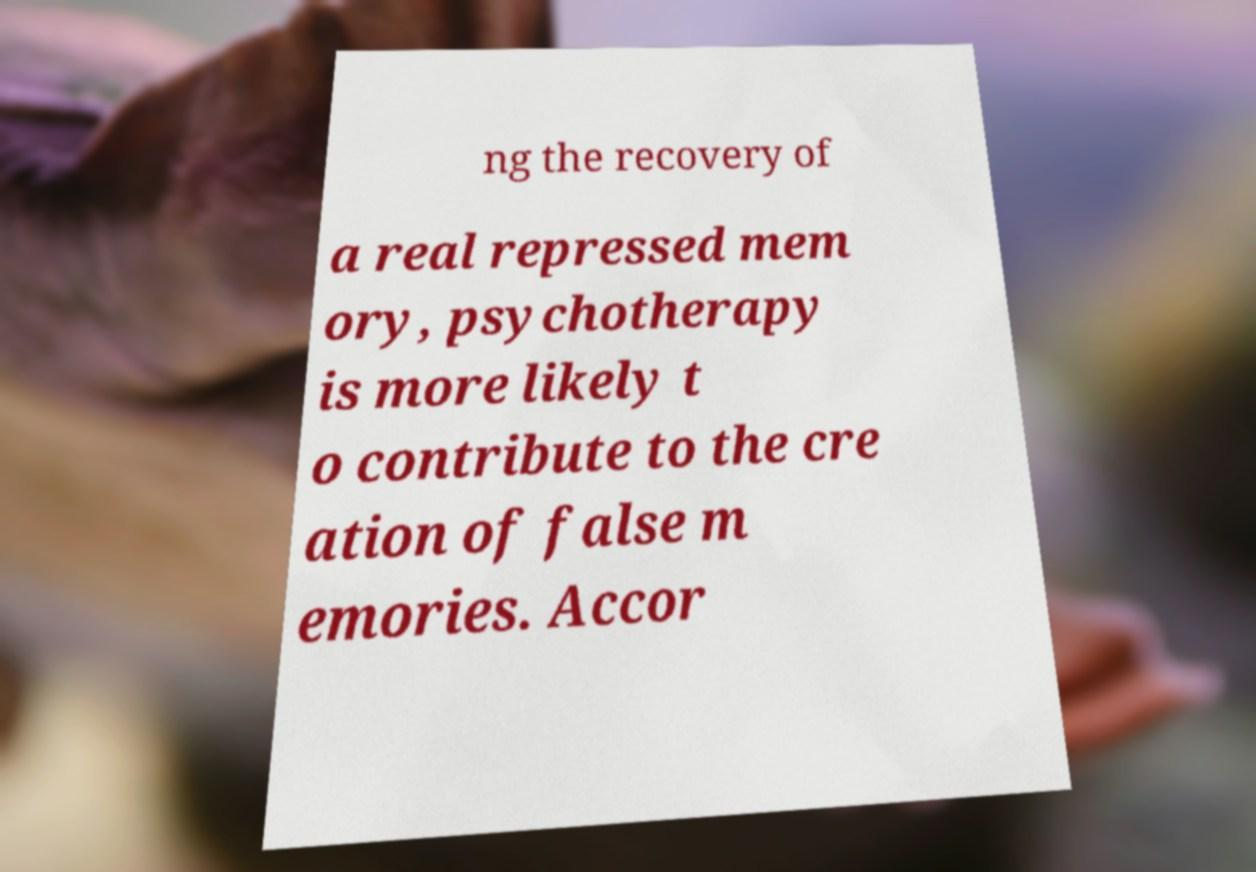There's text embedded in this image that I need extracted. Can you transcribe it verbatim? ng the recovery of a real repressed mem ory, psychotherapy is more likely t o contribute to the cre ation of false m emories. Accor 